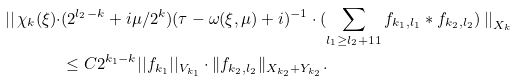<formula> <loc_0><loc_0><loc_500><loc_500>\left | \right | \chi _ { k } ( \xi ) \cdot & ( 2 ^ { l _ { 2 } - k } + i \mu / 2 ^ { k } ) ( \tau - \omega ( \xi , \mu ) + i ) ^ { - 1 } \cdot ( \sum _ { l _ { 1 } \geq l _ { 2 } + 1 1 } f _ { k _ { 1 } , l _ { 1 } } \ast f _ { k _ { 2 } , l _ { 2 } } ) \left | \right | _ { X _ { k } } \\ & \leq C 2 ^ { k _ { 1 } - k } | | f _ { k _ { 1 } } | | _ { V _ { k _ { 1 } } } \cdot \| f _ { k _ { 2 } , l _ { 2 } } \| _ { X _ { k _ { 2 } } + Y _ { k _ { 2 } } } .</formula> 